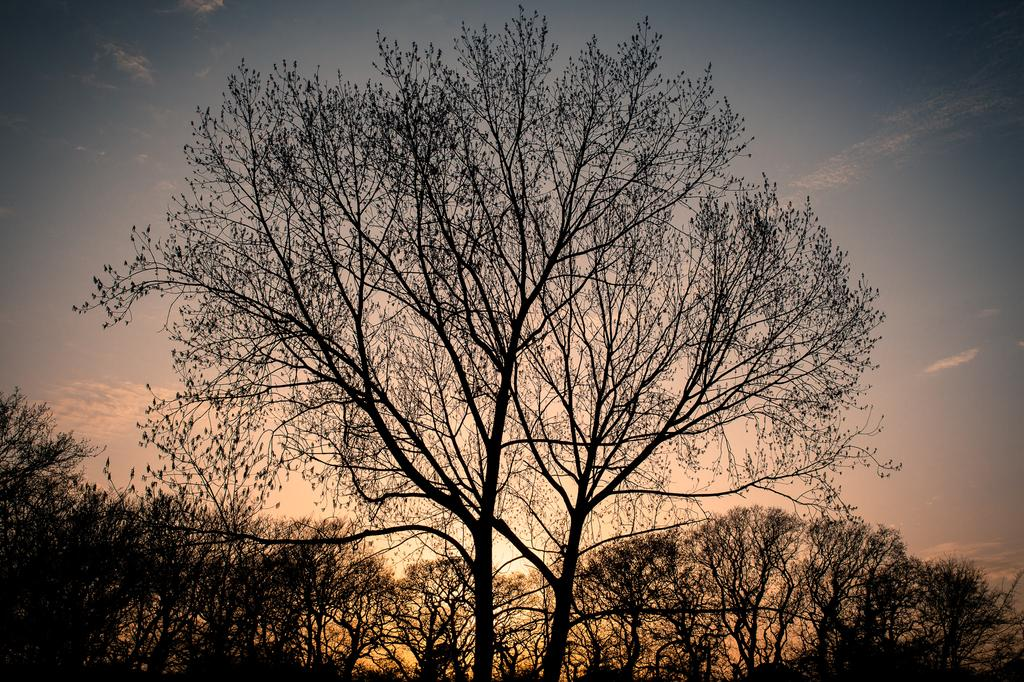What type of vegetation can be seen in the image? There are trees in the image. What part of the natural environment is visible in the image? The sky is visible in the image. What is the volume level of the father in the image? There is no father present in the image, so it is not possible to determine the volume level of a father. 